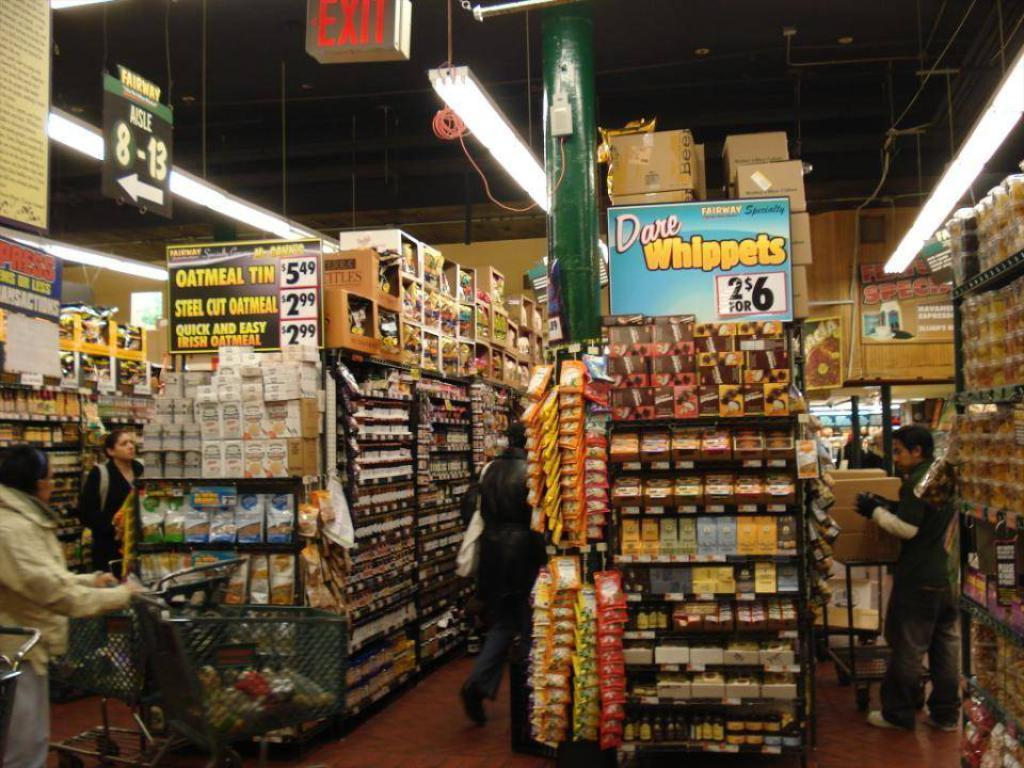<image>
Describe the image concisely. Grocery store with a large variety of goods Dare Wippets are two for six dollars. 